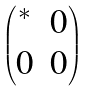<formula> <loc_0><loc_0><loc_500><loc_500>\begin{pmatrix} ^ { * } & 0 \\ 0 & 0 \end{pmatrix}</formula> 